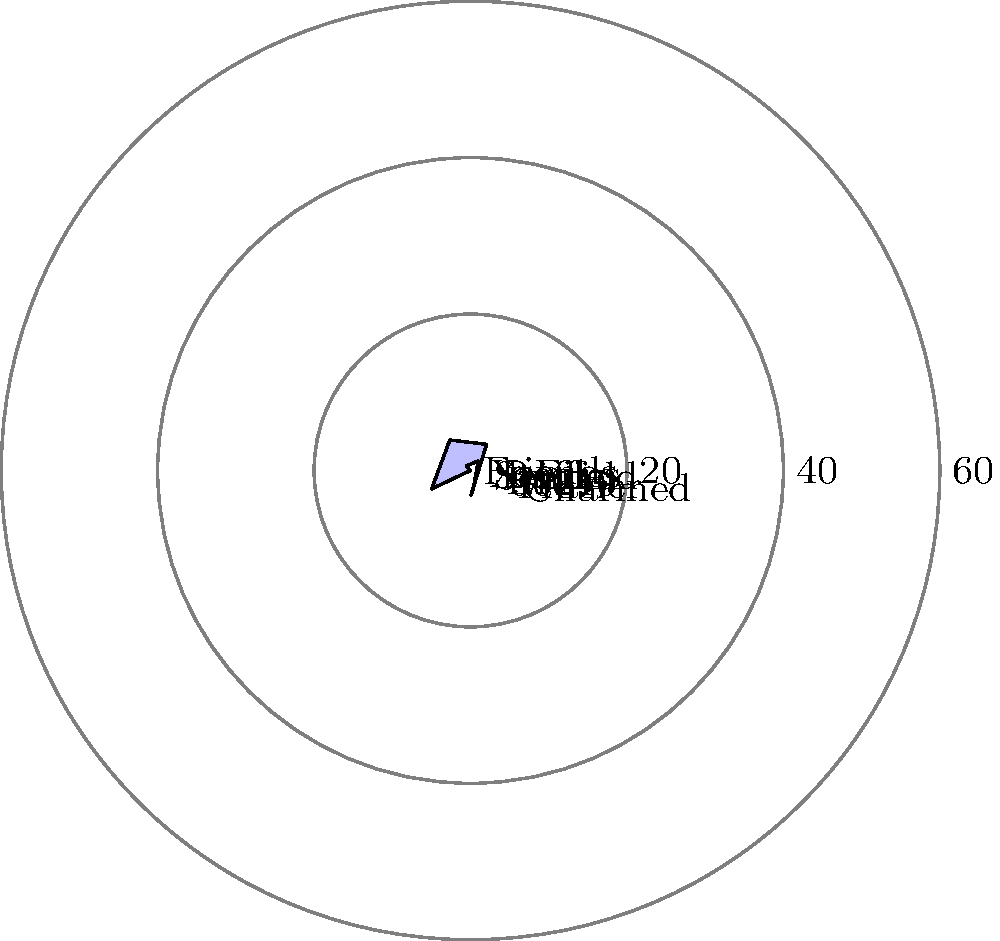Based on the polar area diagram representing the distribution of male vs. female lead roles in popular 90's TV shows, which show had the highest percentage of female lead roles? To determine which show had the highest percentage of female lead roles, we need to analyze the polar area diagram:

1. The diagram shows 8 popular 90's TV shows.
2. Each show is represented by a sector in the polar area diagram.
3. The radius of each sector represents the percentage of male lead roles.
4. Therefore, the shorter the radius, the higher the percentage of female lead roles.
5. Examining the diagram, we can see that:
   - Friends: 60% male leads
   - X-Files: 40% male leads
   - Seinfeld: 70% male leads
   - Buffy: 30% male leads
   - ER: 55% male leads
   - 90210: 45% male leads
   - Frasier: 65% male leads
   - Charmed: 35% male leads
6. The shortest radius corresponds to Buffy, with only 30% male leads.
7. This means Buffy has the highest percentage of female lead roles at 70%.

Therefore, Buffy the Vampire Slayer had the highest percentage of female lead roles among the shows represented in the diagram.
Answer: Buffy the Vampire Slayer 